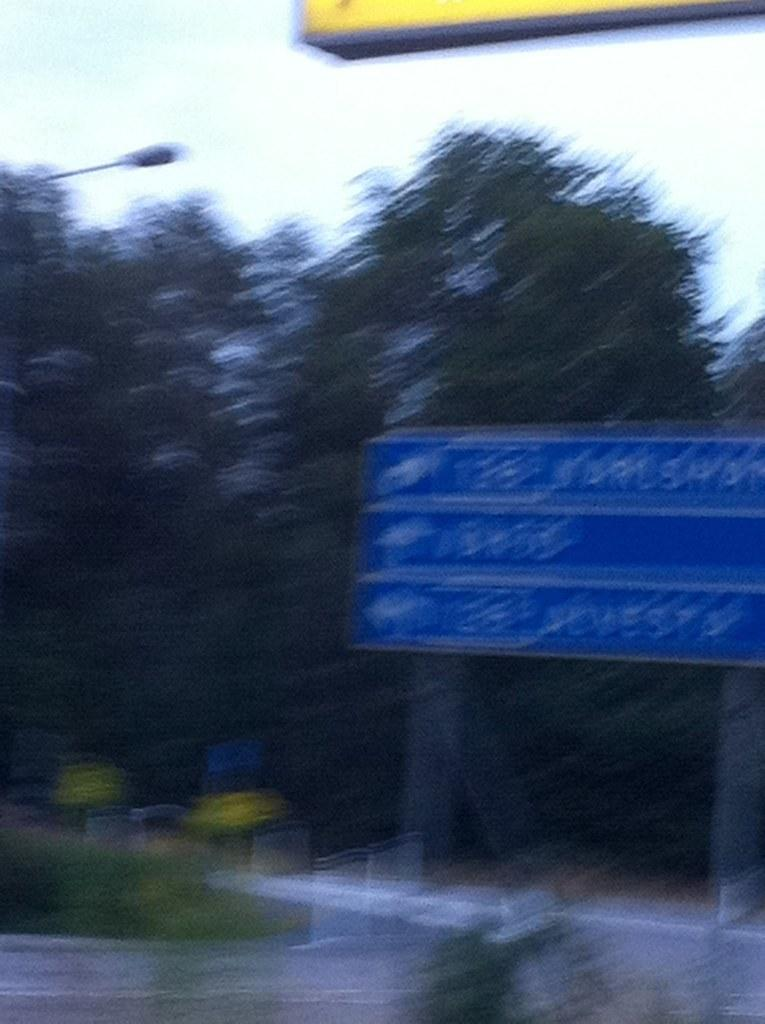What objects are in the foreground of the image? There are boards, trees, and a pole in the foreground of the image. What type of surface can be seen at the bottom of the image? There is a road visible at the bottom of the image. What type of tooth can be seen in the image? There is no tooth present in the image. How many hours are visible in the image? There is no indication of time or hours in the image. 